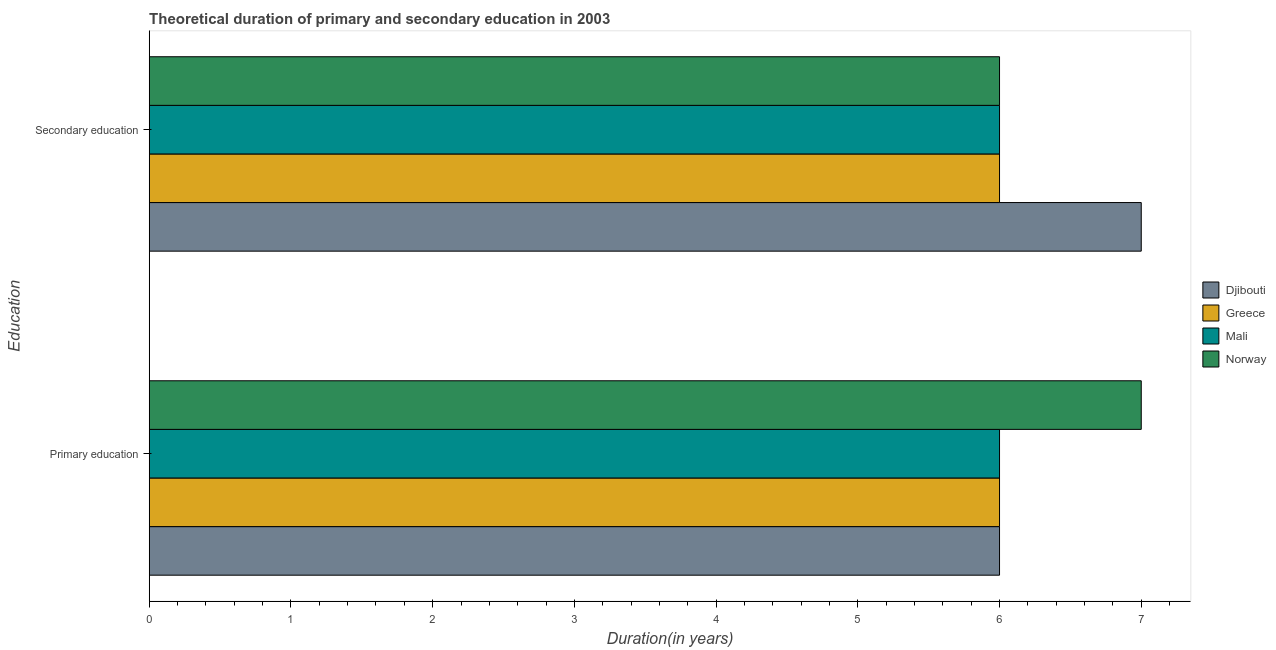How many groups of bars are there?
Provide a short and direct response. 2. Are the number of bars per tick equal to the number of legend labels?
Provide a succinct answer. Yes. Are the number of bars on each tick of the Y-axis equal?
Provide a short and direct response. Yes. What is the label of the 1st group of bars from the top?
Offer a terse response. Secondary education. What is the duration of primary education in Mali?
Your answer should be very brief. 6. Across all countries, what is the maximum duration of secondary education?
Offer a terse response. 7. Across all countries, what is the minimum duration of primary education?
Provide a succinct answer. 6. In which country was the duration of secondary education maximum?
Make the answer very short. Djibouti. In which country was the duration of secondary education minimum?
Provide a short and direct response. Greece. What is the total duration of secondary education in the graph?
Keep it short and to the point. 25. What is the difference between the duration of primary education in Mali and that in Norway?
Give a very brief answer. -1. What is the average duration of primary education per country?
Make the answer very short. 6.25. What is the difference between the duration of primary education and duration of secondary education in Norway?
Your response must be concise. 1. In how many countries, is the duration of primary education greater than 1.8 years?
Provide a short and direct response. 4. What is the ratio of the duration of primary education in Greece to that in Djibouti?
Your response must be concise. 1. Is the duration of secondary education in Norway less than that in Djibouti?
Give a very brief answer. Yes. What does the 4th bar from the top in Primary education represents?
Make the answer very short. Djibouti. What does the 1st bar from the bottom in Primary education represents?
Your answer should be very brief. Djibouti. How many bars are there?
Keep it short and to the point. 8. How many legend labels are there?
Give a very brief answer. 4. How are the legend labels stacked?
Offer a very short reply. Vertical. What is the title of the graph?
Ensure brevity in your answer.  Theoretical duration of primary and secondary education in 2003. What is the label or title of the X-axis?
Your answer should be very brief. Duration(in years). What is the label or title of the Y-axis?
Provide a succinct answer. Education. What is the Duration(in years) of Djibouti in Primary education?
Offer a very short reply. 6. What is the Duration(in years) of Greece in Primary education?
Give a very brief answer. 6. What is the Duration(in years) of Mali in Primary education?
Give a very brief answer. 6. What is the Duration(in years) of Norway in Primary education?
Provide a short and direct response. 7. What is the Duration(in years) of Djibouti in Secondary education?
Give a very brief answer. 7. Across all Education, what is the maximum Duration(in years) in Djibouti?
Offer a very short reply. 7. Across all Education, what is the maximum Duration(in years) of Greece?
Provide a short and direct response. 6. Across all Education, what is the minimum Duration(in years) in Greece?
Provide a short and direct response. 6. Across all Education, what is the minimum Duration(in years) in Mali?
Offer a terse response. 6. What is the total Duration(in years) in Mali in the graph?
Provide a succinct answer. 12. What is the difference between the Duration(in years) of Norway in Primary education and that in Secondary education?
Provide a short and direct response. 1. What is the difference between the Duration(in years) in Djibouti in Primary education and the Duration(in years) in Mali in Secondary education?
Your answer should be very brief. 0. What is the difference between the Duration(in years) in Greece in Primary education and the Duration(in years) in Mali in Secondary education?
Your answer should be very brief. 0. What is the average Duration(in years) of Djibouti per Education?
Ensure brevity in your answer.  6.5. What is the average Duration(in years) in Greece per Education?
Offer a very short reply. 6. What is the average Duration(in years) of Norway per Education?
Provide a succinct answer. 6.5. What is the difference between the Duration(in years) of Djibouti and Duration(in years) of Greece in Primary education?
Your answer should be very brief. 0. What is the difference between the Duration(in years) in Djibouti and Duration(in years) in Norway in Primary education?
Your answer should be very brief. -1. What is the difference between the Duration(in years) of Greece and Duration(in years) of Norway in Primary education?
Provide a short and direct response. -1. What is the difference between the Duration(in years) of Mali and Duration(in years) of Norway in Primary education?
Offer a very short reply. -1. What is the difference between the Duration(in years) in Greece and Duration(in years) in Norway in Secondary education?
Your answer should be very brief. 0. What is the ratio of the Duration(in years) of Djibouti in Primary education to that in Secondary education?
Your answer should be very brief. 0.86. What is the difference between the highest and the second highest Duration(in years) of Djibouti?
Give a very brief answer. 1. What is the difference between the highest and the second highest Duration(in years) in Mali?
Give a very brief answer. 0. What is the difference between the highest and the lowest Duration(in years) of Greece?
Your answer should be very brief. 0. What is the difference between the highest and the lowest Duration(in years) in Norway?
Offer a very short reply. 1. 